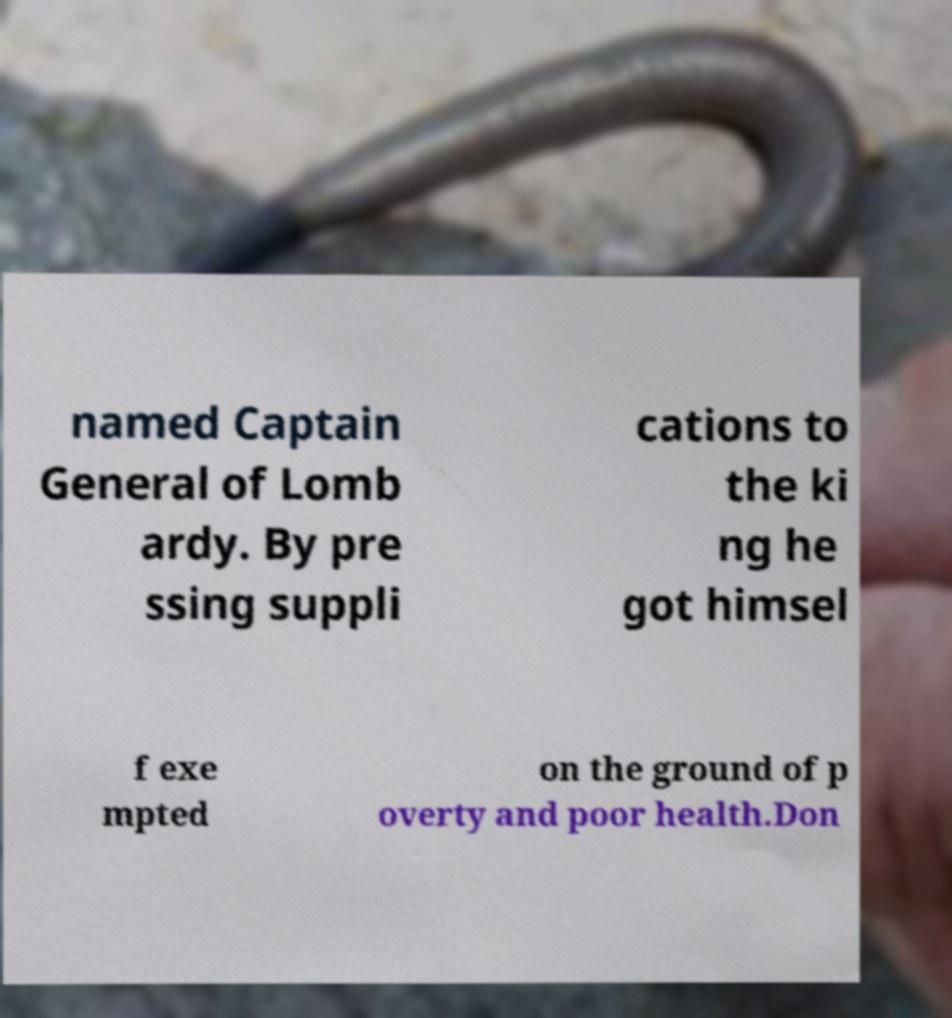What messages or text are displayed in this image? I need them in a readable, typed format. named Captain General of Lomb ardy. By pre ssing suppli cations to the ki ng he got himsel f exe mpted on the ground of p overty and poor health.Don 